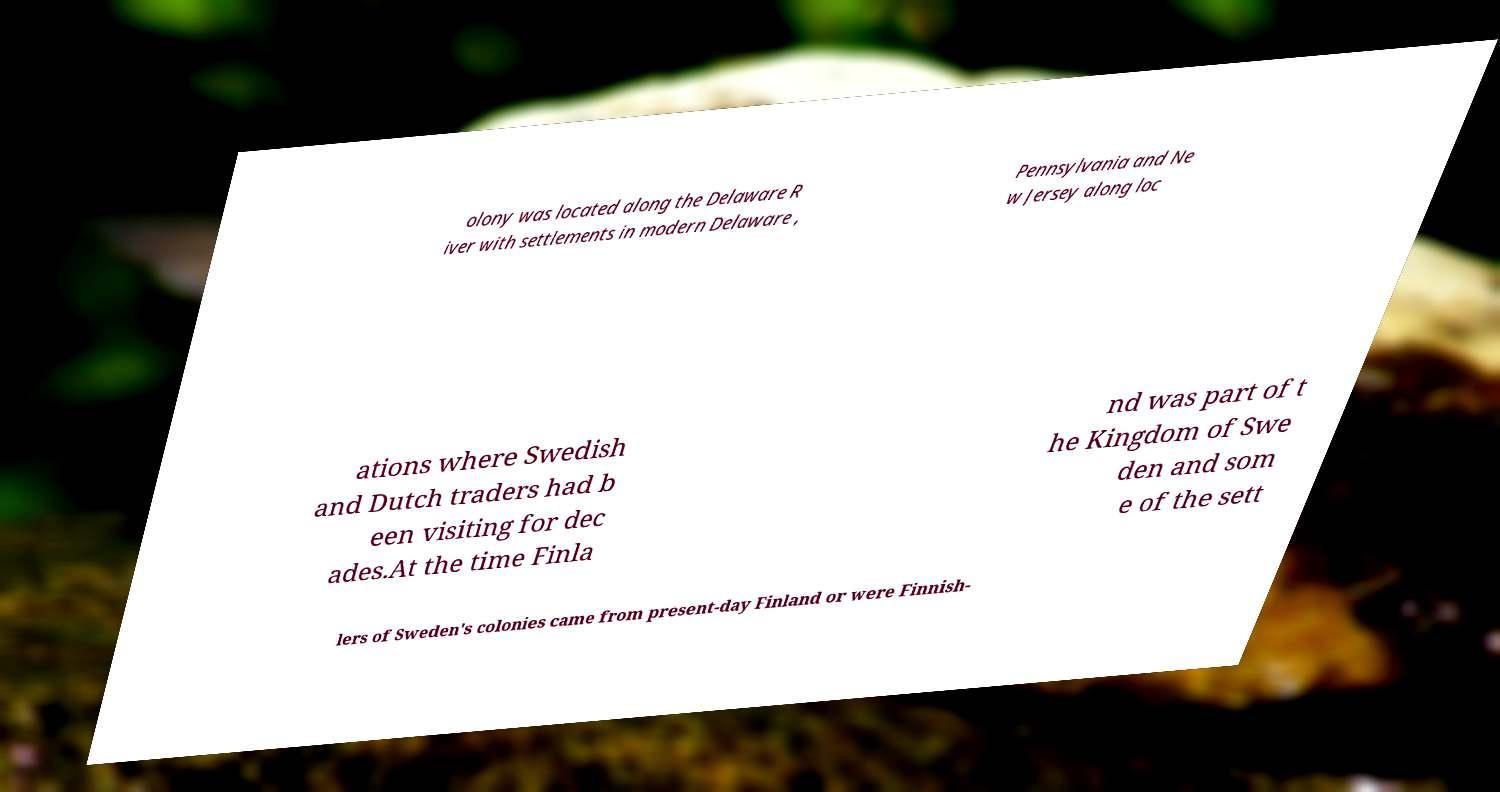There's text embedded in this image that I need extracted. Can you transcribe it verbatim? olony was located along the Delaware R iver with settlements in modern Delaware , Pennsylvania and Ne w Jersey along loc ations where Swedish and Dutch traders had b een visiting for dec ades.At the time Finla nd was part of t he Kingdom of Swe den and som e of the sett lers of Sweden's colonies came from present-day Finland or were Finnish- 